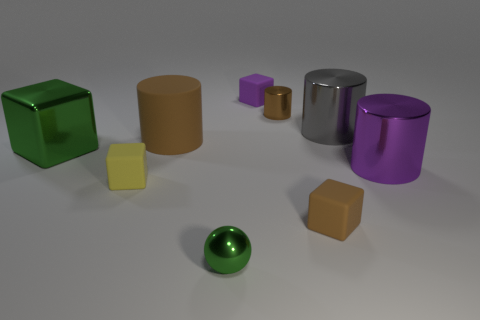What is the size of the brown metallic thing that is on the right side of the green block?
Your response must be concise. Small. The matte block that is behind the brown cylinder to the left of the small rubber block that is behind the big green block is what color?
Offer a very short reply. Purple. There is a small metal object that is in front of the tiny matte cube that is in front of the tiny yellow rubber thing; what is its color?
Provide a succinct answer. Green. Is the number of big brown objects that are in front of the tiny yellow rubber thing greater than the number of small brown rubber blocks that are behind the gray metallic cylinder?
Give a very brief answer. No. Are the tiny brown object that is behind the tiny yellow thing and the large thing behind the large rubber thing made of the same material?
Provide a succinct answer. Yes. Are there any small green shiny spheres to the right of the green ball?
Your response must be concise. No. How many gray objects are either tiny metallic things or small metallic spheres?
Offer a terse response. 0. Is the gray cylinder made of the same material as the brown cylinder that is to the left of the small green object?
Keep it short and to the point. No. What is the size of the brown rubber object that is the same shape as the gray shiny thing?
Give a very brief answer. Large. What material is the large green object?
Keep it short and to the point. Metal. 